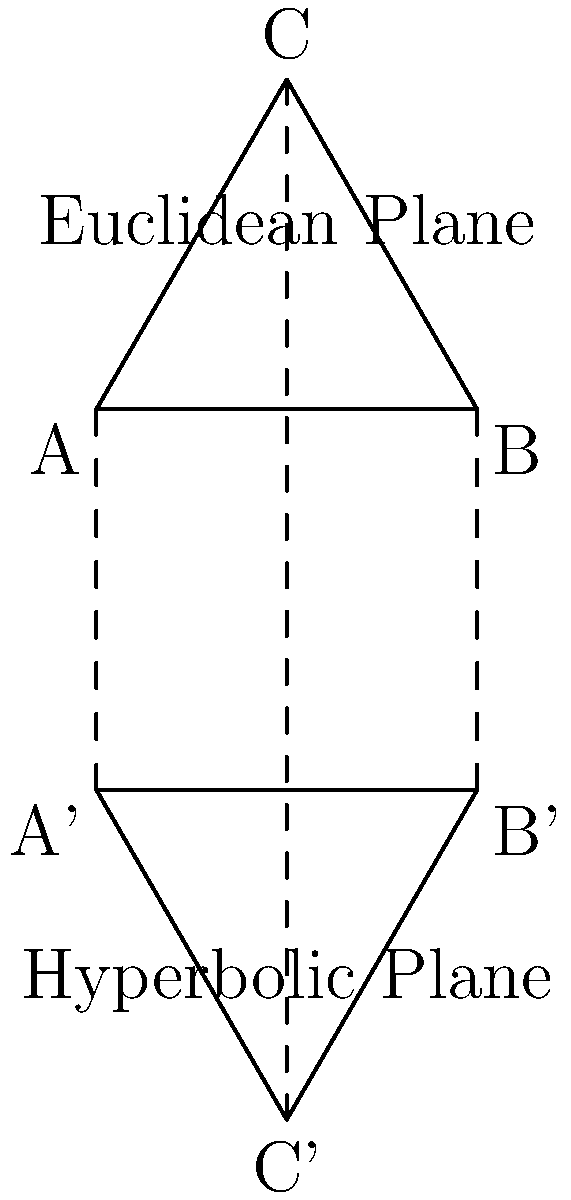In the diagram, two similar equilateral triangles are shown: one in the Euclidean plane (ABC) and one in the hyperbolic plane (A'B'C'). If the area of triangle ABC is 1 unit² and the side length of A'B'C' is twice that of ABC, what is the approximate area of triangle A'B'C' in the hyperbolic plane? (Assume the curvature constant k = -1 for the hyperbolic plane) To solve this problem, we need to follow these steps:

1) In Euclidean geometry, when we double the side length of a triangle, its area increases by a factor of 4.

2) However, in hyperbolic geometry, this relationship doesn't hold. We need to use the formula for the area of a triangle in hyperbolic geometry:

   $$A = (α + β + γ - π)k^{-2}$$

   where A is the area, α, β, γ are the angles of the triangle, k is the curvature constant, and π is pi.

3) For an equilateral triangle in hyperbolic geometry with side length a, the angle θ is given by:

   $$\cos(\frac{\theta}{2}) = \frac{\cosh(\frac{a}{2})}{\cosh(a)}$$

4) Given k = -1, and knowing that doubling the side length means a = 2 for A'B'C' (assuming a = 1 for ABC), we can calculate:

   $$\cos(\frac{\theta}{2}) = \frac{\cosh(1)}{\cosh(2)} \approx 0.6481$$

5) This gives us θ ≈ 1.5545 radians or about 89.09°

6) Now we can use the area formula:

   $$A = (3 * 1.5545 - π) * (-1)^{-2} \approx 0.8354$$

7) Therefore, the area of A'B'C' is approximately 0.8354 unit².

8) Comparing this to the original triangle's area of 1 unit², we see that doubling the side length in hyperbolic geometry results in a smaller increase in area compared to Euclidean geometry.
Answer: 0.8354 unit² 